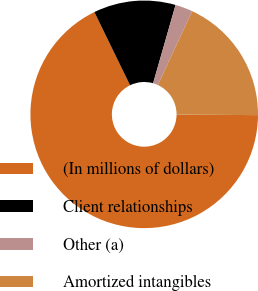<chart> <loc_0><loc_0><loc_500><loc_500><pie_chart><fcel>(In millions of dollars)<fcel>Client relationships<fcel>Other (a)<fcel>Amortized intangibles<nl><fcel>67.68%<fcel>11.66%<fcel>2.49%<fcel>18.18%<nl></chart> 